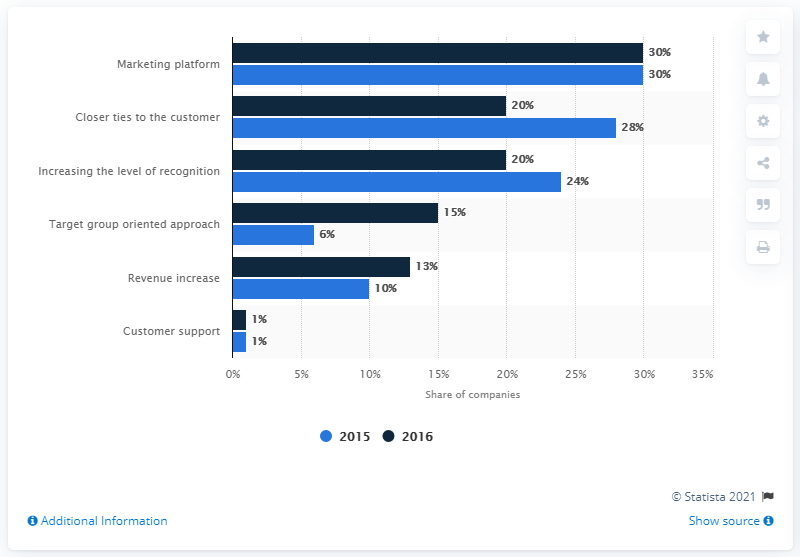Highlight a few significant elements in this photo. The main reason with the highest number in 2015 was marketing platform. The difference between the shortest light blue bar and the tallest dark blue bar is 29 